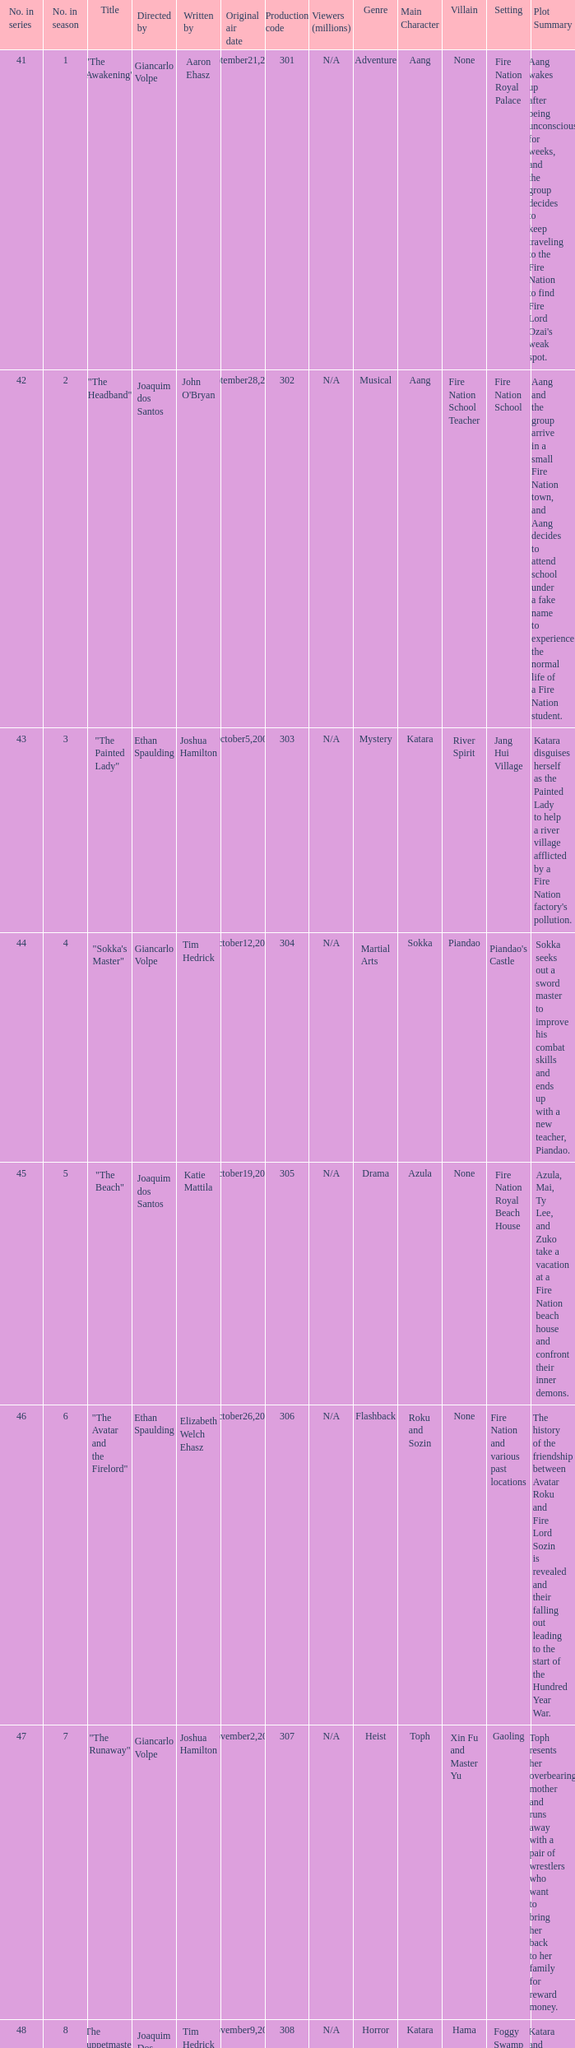What are all the numbers in the series with an episode title of "the beach"? 45.0. 